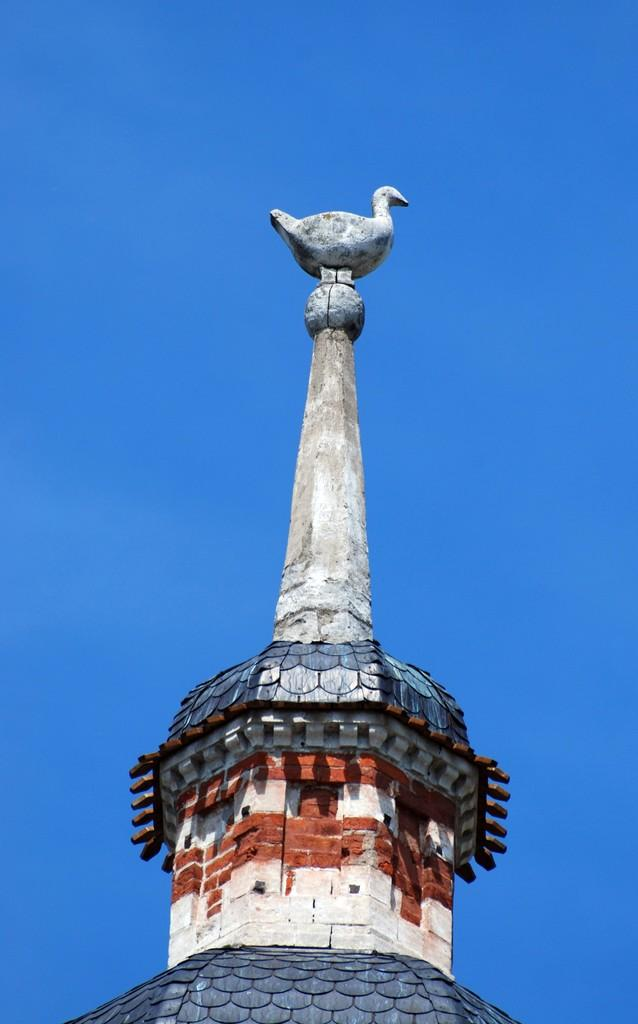What is the main structure in the image? There is a building in the image. What decorative element is present on the building? There is a statue of a bird on the building. What can be seen in the background of the image? The sky is visible in the background of the image. What type of food is being served at the table in the image? There is no table or food present in the image; it only features a building with a statue of a bird and the sky in the background. 